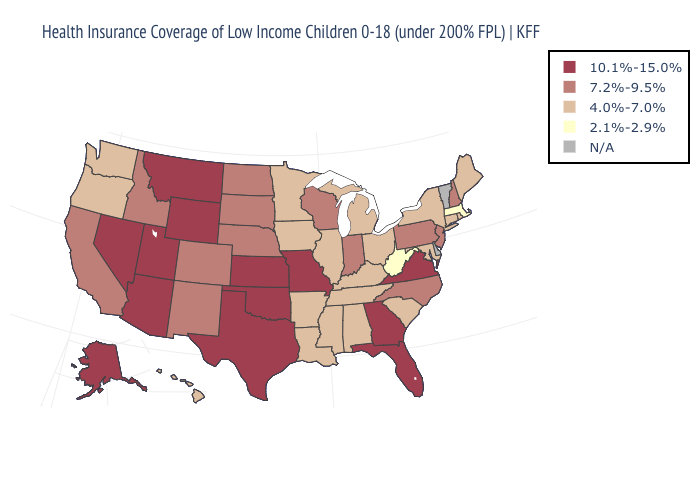Which states have the lowest value in the West?
Keep it brief. Hawaii, Oregon, Washington. How many symbols are there in the legend?
Keep it brief. 5. What is the highest value in the South ?
Keep it brief. 10.1%-15.0%. What is the highest value in the USA?
Short answer required. 10.1%-15.0%. Which states have the lowest value in the USA?
Concise answer only. Massachusetts, West Virginia. What is the value of Nebraska?
Be succinct. 7.2%-9.5%. Which states have the lowest value in the USA?
Short answer required. Massachusetts, West Virginia. What is the value of Arizona?
Be succinct. 10.1%-15.0%. What is the highest value in the USA?
Keep it brief. 10.1%-15.0%. Among the states that border Oklahoma , does Kansas have the lowest value?
Short answer required. No. What is the value of Michigan?
Short answer required. 4.0%-7.0%. Name the states that have a value in the range 2.1%-2.9%?
Keep it brief. Massachusetts, West Virginia. What is the value of Ohio?
Short answer required. 4.0%-7.0%. Which states have the lowest value in the Northeast?
Be succinct. Massachusetts. 